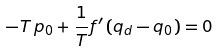Convert formula to latex. <formula><loc_0><loc_0><loc_500><loc_500>- T \, p _ { 0 } + \frac { 1 } { T } f ^ { \prime } \left ( q _ { d } - q _ { 0 } \right ) = 0</formula> 